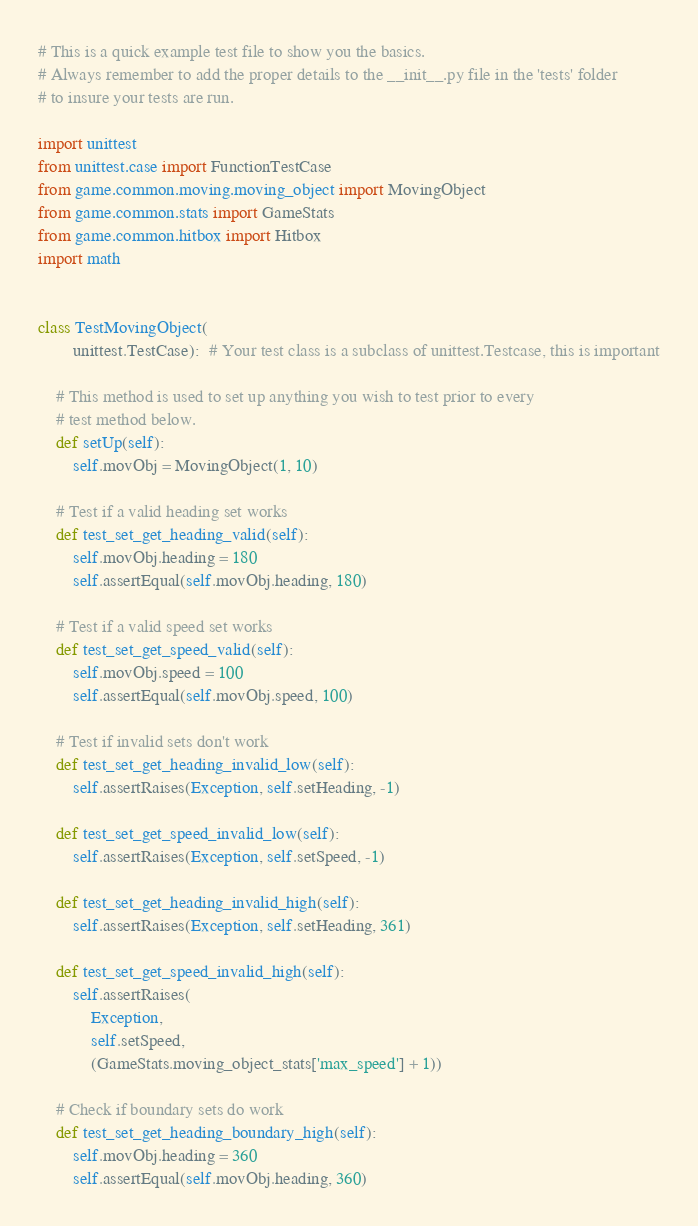<code> <loc_0><loc_0><loc_500><loc_500><_Python_># This is a quick example test file to show you the basics.
# Always remember to add the proper details to the __init__.py file in the 'tests' folder
# to insure your tests are run.

import unittest
from unittest.case import FunctionTestCase
from game.common.moving.moving_object import MovingObject
from game.common.stats import GameStats
from game.common.hitbox import Hitbox
import math


class TestMovingObject(
        unittest.TestCase):  # Your test class is a subclass of unittest.Testcase, this is important

    # This method is used to set up anything you wish to test prior to every
    # test method below.
    def setUp(self):
        self.movObj = MovingObject(1, 10)

    # Test if a valid heading set works
    def test_set_get_heading_valid(self):
        self.movObj.heading = 180
        self.assertEqual(self.movObj.heading, 180)

    # Test if a valid speed set works
    def test_set_get_speed_valid(self):
        self.movObj.speed = 100
        self.assertEqual(self.movObj.speed, 100)

    # Test if invalid sets don't work
    def test_set_get_heading_invalid_low(self):
        self.assertRaises(Exception, self.setHeading, -1)

    def test_set_get_speed_invalid_low(self):
        self.assertRaises(Exception, self.setSpeed, -1)

    def test_set_get_heading_invalid_high(self):
        self.assertRaises(Exception, self.setHeading, 361)

    def test_set_get_speed_invalid_high(self):
        self.assertRaises(
            Exception,
            self.setSpeed,
            (GameStats.moving_object_stats['max_speed'] + 1))

    # Check if boundary sets do work
    def test_set_get_heading_boundary_high(self):
        self.movObj.heading = 360
        self.assertEqual(self.movObj.heading, 360)
</code> 